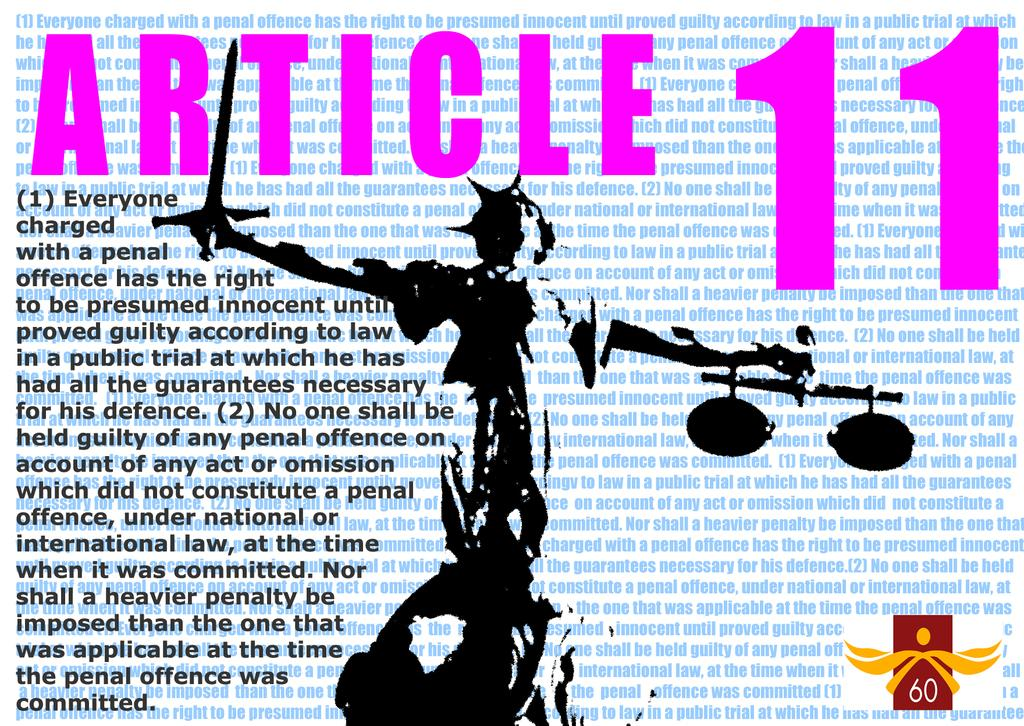Provide a one-sentence caption for the provided image. The statue of liberty is below the text Article 11. 